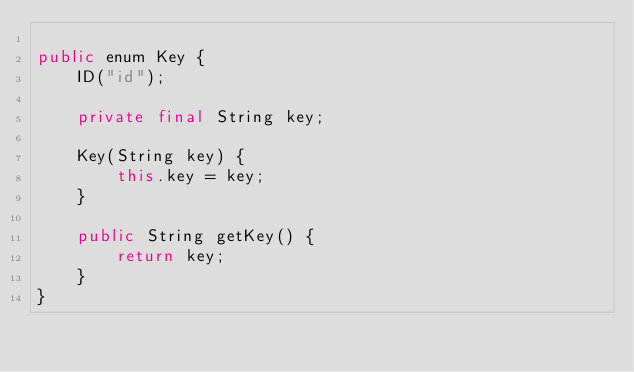Convert code to text. <code><loc_0><loc_0><loc_500><loc_500><_Java_>
public enum Key {
    ID("id");

    private final String key;

    Key(String key) {
        this.key = key;
    }

    public String getKey() {
        return key;
    }
}
</code> 